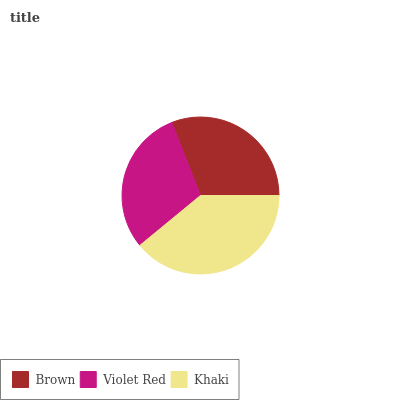Is Violet Red the minimum?
Answer yes or no. Yes. Is Khaki the maximum?
Answer yes or no. Yes. Is Khaki the minimum?
Answer yes or no. No. Is Violet Red the maximum?
Answer yes or no. No. Is Khaki greater than Violet Red?
Answer yes or no. Yes. Is Violet Red less than Khaki?
Answer yes or no. Yes. Is Violet Red greater than Khaki?
Answer yes or no. No. Is Khaki less than Violet Red?
Answer yes or no. No. Is Brown the high median?
Answer yes or no. Yes. Is Brown the low median?
Answer yes or no. Yes. Is Violet Red the high median?
Answer yes or no. No. Is Khaki the low median?
Answer yes or no. No. 